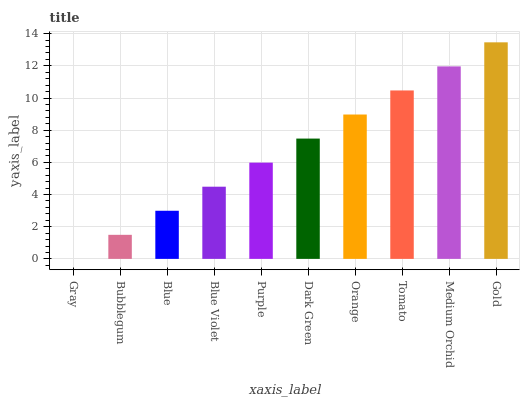Is Bubblegum the minimum?
Answer yes or no. No. Is Bubblegum the maximum?
Answer yes or no. No. Is Bubblegum greater than Gray?
Answer yes or no. Yes. Is Gray less than Bubblegum?
Answer yes or no. Yes. Is Gray greater than Bubblegum?
Answer yes or no. No. Is Bubblegum less than Gray?
Answer yes or no. No. Is Dark Green the high median?
Answer yes or no. Yes. Is Purple the low median?
Answer yes or no. Yes. Is Purple the high median?
Answer yes or no. No. Is Dark Green the low median?
Answer yes or no. No. 